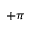<formula> <loc_0><loc_0><loc_500><loc_500>+ \pi</formula> 